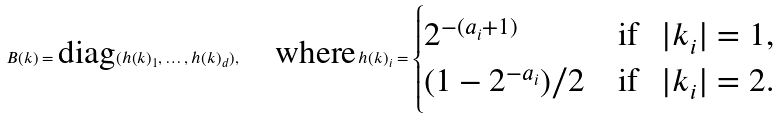Convert formula to latex. <formula><loc_0><loc_0><loc_500><loc_500>B ( k ) = \text {diag} ( h ( k ) _ { 1 } , \dots , h ( k ) _ { d } ) , \quad \text {where} \, h ( k ) _ { i } = \begin{cases} 2 ^ { - ( a _ { i } + 1 ) } & \text {if \, $|k_{i}| = 1$,} \\ ( 1 - 2 ^ { - a _ { i } } ) / 2 & \text {if \, $|k_{i}| = 2$.} \end{cases}</formula> 